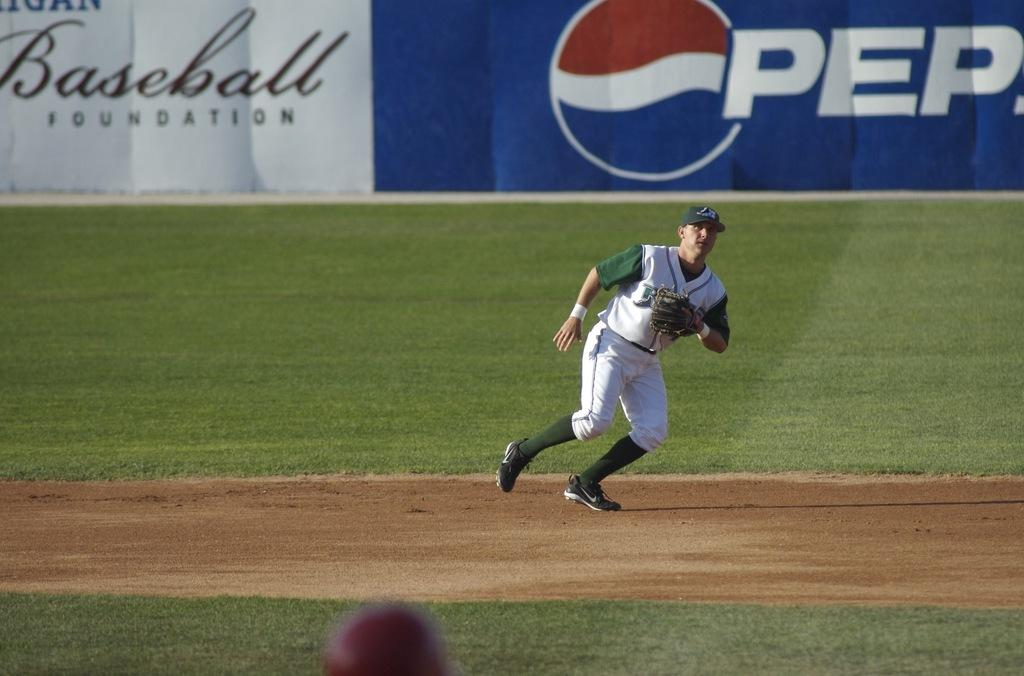<image>
Summarize the visual content of the image. Both Pepsi and The Baseball Foundation have bought ad space at the sidelines of this baseball field. 